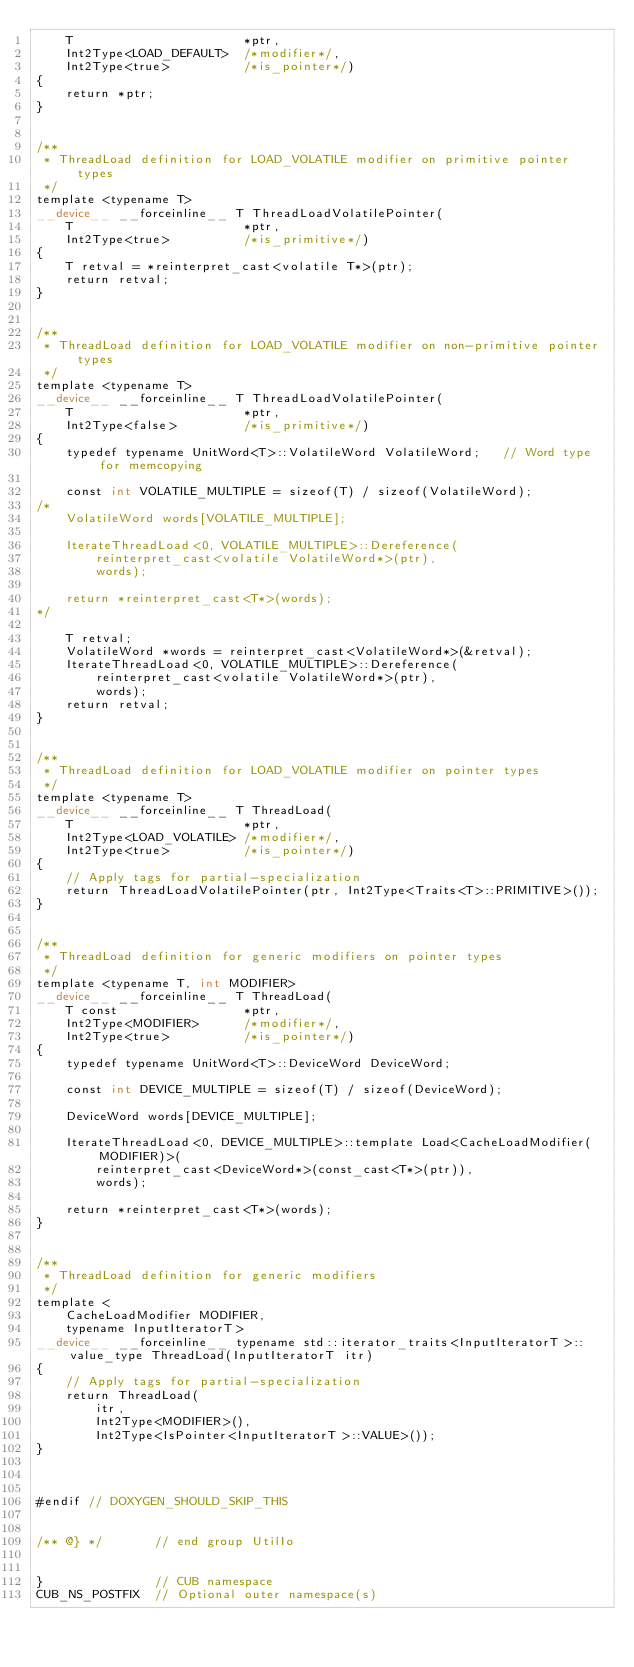<code> <loc_0><loc_0><loc_500><loc_500><_Cuda_>    T                       *ptr,
    Int2Type<LOAD_DEFAULT>  /*modifier*/,
    Int2Type<true>          /*is_pointer*/)
{
    return *ptr;
}


/**
 * ThreadLoad definition for LOAD_VOLATILE modifier on primitive pointer types
 */
template <typename T>
__device__ __forceinline__ T ThreadLoadVolatilePointer(
    T                       *ptr,
    Int2Type<true>          /*is_primitive*/)
{
    T retval = *reinterpret_cast<volatile T*>(ptr);
    return retval;
}


/**
 * ThreadLoad definition for LOAD_VOLATILE modifier on non-primitive pointer types
 */
template <typename T>
__device__ __forceinline__ T ThreadLoadVolatilePointer(
    T                       *ptr,
    Int2Type<false>         /*is_primitive*/)
{
    typedef typename UnitWord<T>::VolatileWord VolatileWord;   // Word type for memcopying

    const int VOLATILE_MULTIPLE = sizeof(T) / sizeof(VolatileWord);
/*
    VolatileWord words[VOLATILE_MULTIPLE];

    IterateThreadLoad<0, VOLATILE_MULTIPLE>::Dereference(
        reinterpret_cast<volatile VolatileWord*>(ptr),
        words);

    return *reinterpret_cast<T*>(words);
*/

    T retval;
    VolatileWord *words = reinterpret_cast<VolatileWord*>(&retval);
    IterateThreadLoad<0, VOLATILE_MULTIPLE>::Dereference(
        reinterpret_cast<volatile VolatileWord*>(ptr),
        words);
    return retval;
}


/**
 * ThreadLoad definition for LOAD_VOLATILE modifier on pointer types
 */
template <typename T>
__device__ __forceinline__ T ThreadLoad(
    T                       *ptr,
    Int2Type<LOAD_VOLATILE> /*modifier*/,
    Int2Type<true>          /*is_pointer*/)
{
    // Apply tags for partial-specialization
    return ThreadLoadVolatilePointer(ptr, Int2Type<Traits<T>::PRIMITIVE>());
}


/**
 * ThreadLoad definition for generic modifiers on pointer types
 */
template <typename T, int MODIFIER>
__device__ __forceinline__ T ThreadLoad(
    T const                 *ptr,
    Int2Type<MODIFIER>      /*modifier*/,
    Int2Type<true>          /*is_pointer*/)
{
    typedef typename UnitWord<T>::DeviceWord DeviceWord;

    const int DEVICE_MULTIPLE = sizeof(T) / sizeof(DeviceWord);

    DeviceWord words[DEVICE_MULTIPLE];

    IterateThreadLoad<0, DEVICE_MULTIPLE>::template Load<CacheLoadModifier(MODIFIER)>(
        reinterpret_cast<DeviceWord*>(const_cast<T*>(ptr)),
        words);

    return *reinterpret_cast<T*>(words);
}


/**
 * ThreadLoad definition for generic modifiers
 */
template <
    CacheLoadModifier MODIFIER,
    typename InputIteratorT>
__device__ __forceinline__ typename std::iterator_traits<InputIteratorT>::value_type ThreadLoad(InputIteratorT itr)
{
    // Apply tags for partial-specialization
    return ThreadLoad(
        itr,
        Int2Type<MODIFIER>(),
        Int2Type<IsPointer<InputIteratorT>::VALUE>());
}



#endif // DOXYGEN_SHOULD_SKIP_THIS


/** @} */       // end group UtilIo


}               // CUB namespace
CUB_NS_POSTFIX  // Optional outer namespace(s)
</code> 